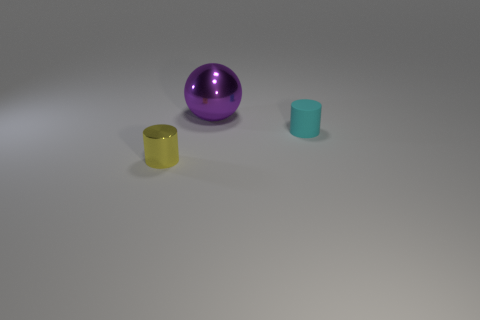The other thing that is made of the same material as the large thing is what size?
Offer a terse response. Small. Is the small matte cylinder the same color as the big thing?
Give a very brief answer. No. Is there a big purple sphere to the left of the tiny thing that is left of the tiny cylinder that is right of the metal sphere?
Make the answer very short. No. How many purple objects have the same size as the cyan object?
Offer a very short reply. 0. Is the size of the shiny thing that is in front of the metallic sphere the same as the sphere that is on the right side of the tiny yellow metallic thing?
Provide a succinct answer. No. The thing that is both on the right side of the shiny cylinder and in front of the purple metal ball has what shape?
Offer a very short reply. Cylinder. Are there any metallic things that have the same color as the tiny shiny cylinder?
Offer a very short reply. No. Are any small yellow things visible?
Your response must be concise. Yes. What is the color of the metal object that is behind the small yellow metallic cylinder?
Offer a terse response. Purple. Does the matte cylinder have the same size as the object on the left side of the large purple ball?
Your answer should be very brief. Yes. 